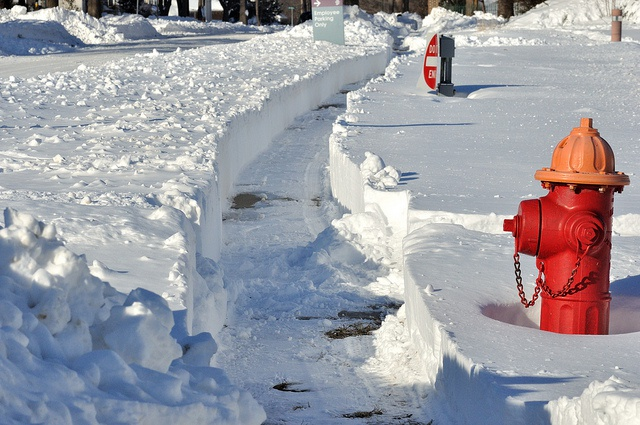Describe the objects in this image and their specific colors. I can see a fire hydrant in black, brown, maroon, and salmon tones in this image. 